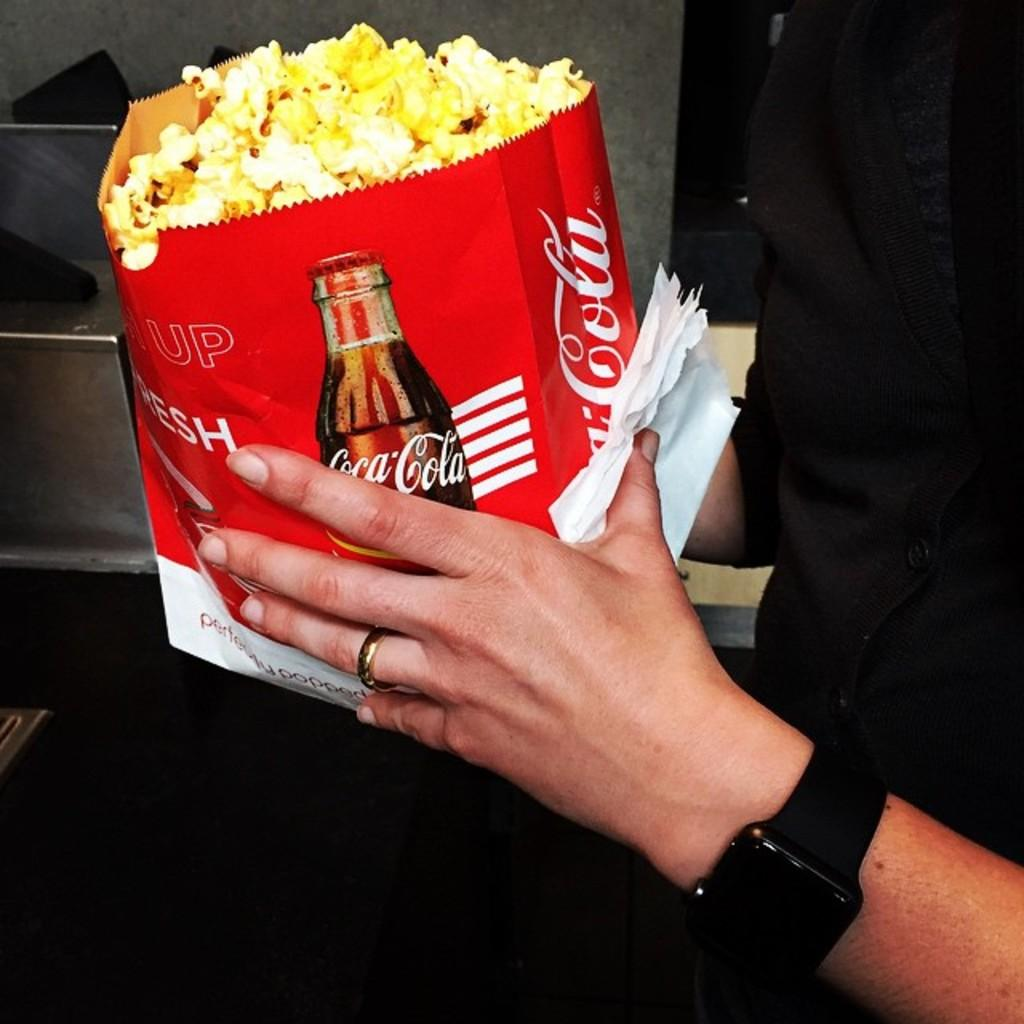<image>
Give a short and clear explanation of the subsequent image. A red and white bag of popcorn with a Coca Cola logo and bottle. 